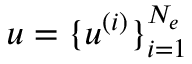<formula> <loc_0><loc_0><loc_500><loc_500>u = \{ u ^ { ( i ) } \} _ { i = 1 } ^ { N _ { e } }</formula> 